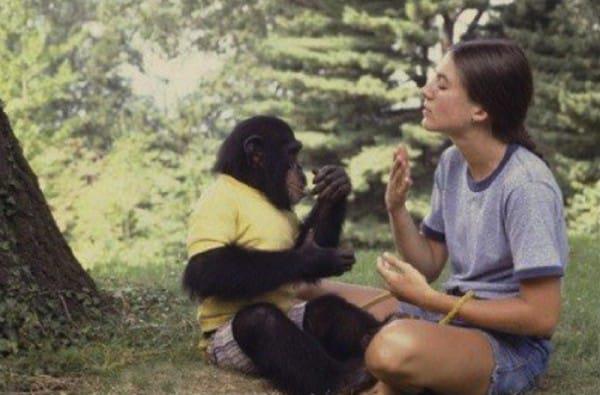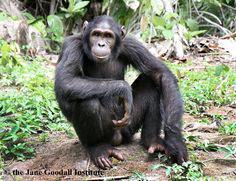The first image is the image on the left, the second image is the image on the right. For the images shown, is this caption "An image contains a human interacting with a chimpanzee." true? Answer yes or no. Yes. The first image is the image on the left, the second image is the image on the right. Examine the images to the left and right. Is the description "In one image, a person is interacting with a chimpanzee, while a second image shows a chimp sitting with its knees drawn up and arms resting on them." accurate? Answer yes or no. Yes. 